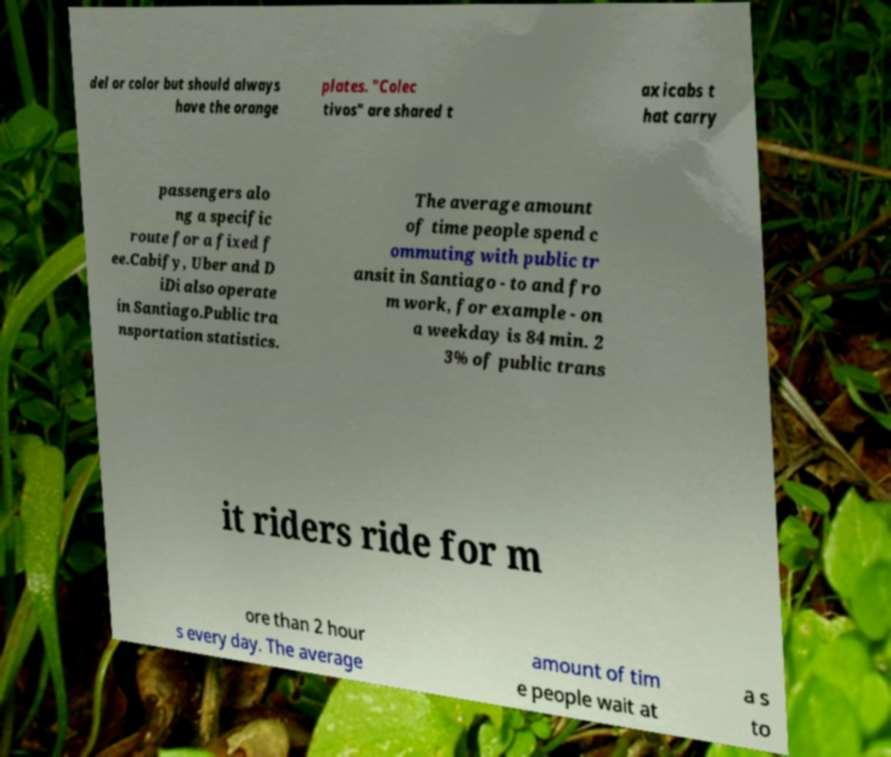For documentation purposes, I need the text within this image transcribed. Could you provide that? del or color but should always have the orange plates. "Colec tivos" are shared t axicabs t hat carry passengers alo ng a specific route for a fixed f ee.Cabify, Uber and D iDi also operate in Santiago.Public tra nsportation statistics. The average amount of time people spend c ommuting with public tr ansit in Santiago - to and fro m work, for example - on a weekday is 84 min. 2 3% of public trans it riders ride for m ore than 2 hour s every day. The average amount of tim e people wait at a s to 